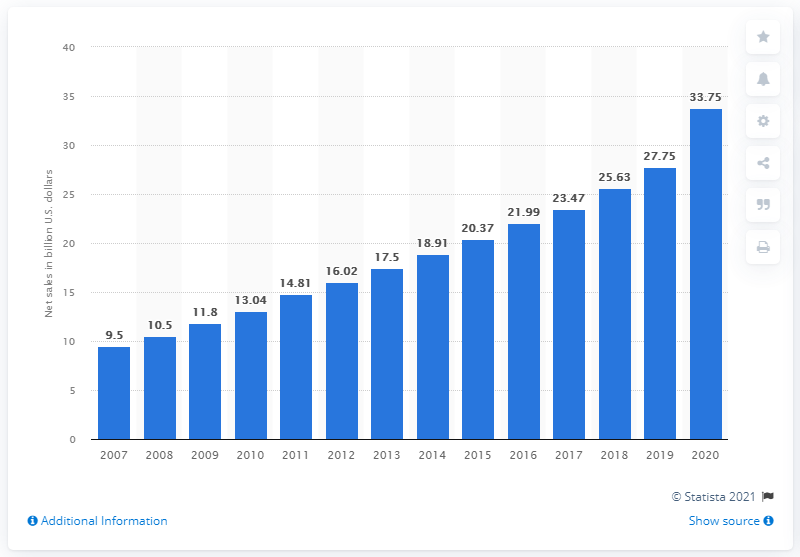Indicate a few pertinent items in this graphic. In 2020, Dollar General's net sales were $33.75 billion. 